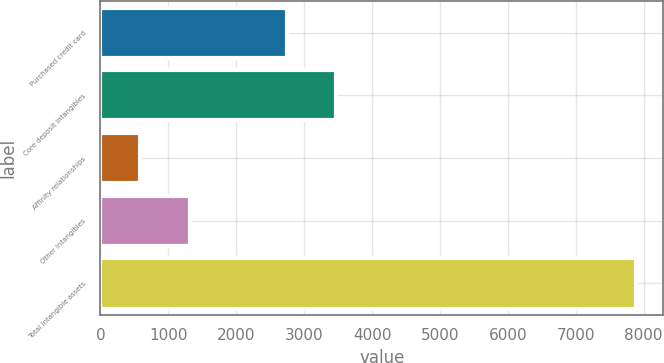<chart> <loc_0><loc_0><loc_500><loc_500><bar_chart><fcel>Purchased credit card<fcel>Core deposit intangibles<fcel>Affinity relationships<fcel>Other intangibles<fcel>Total intangible assets<nl><fcel>2740<fcel>3470.3<fcel>587<fcel>1317.3<fcel>7890<nl></chart> 